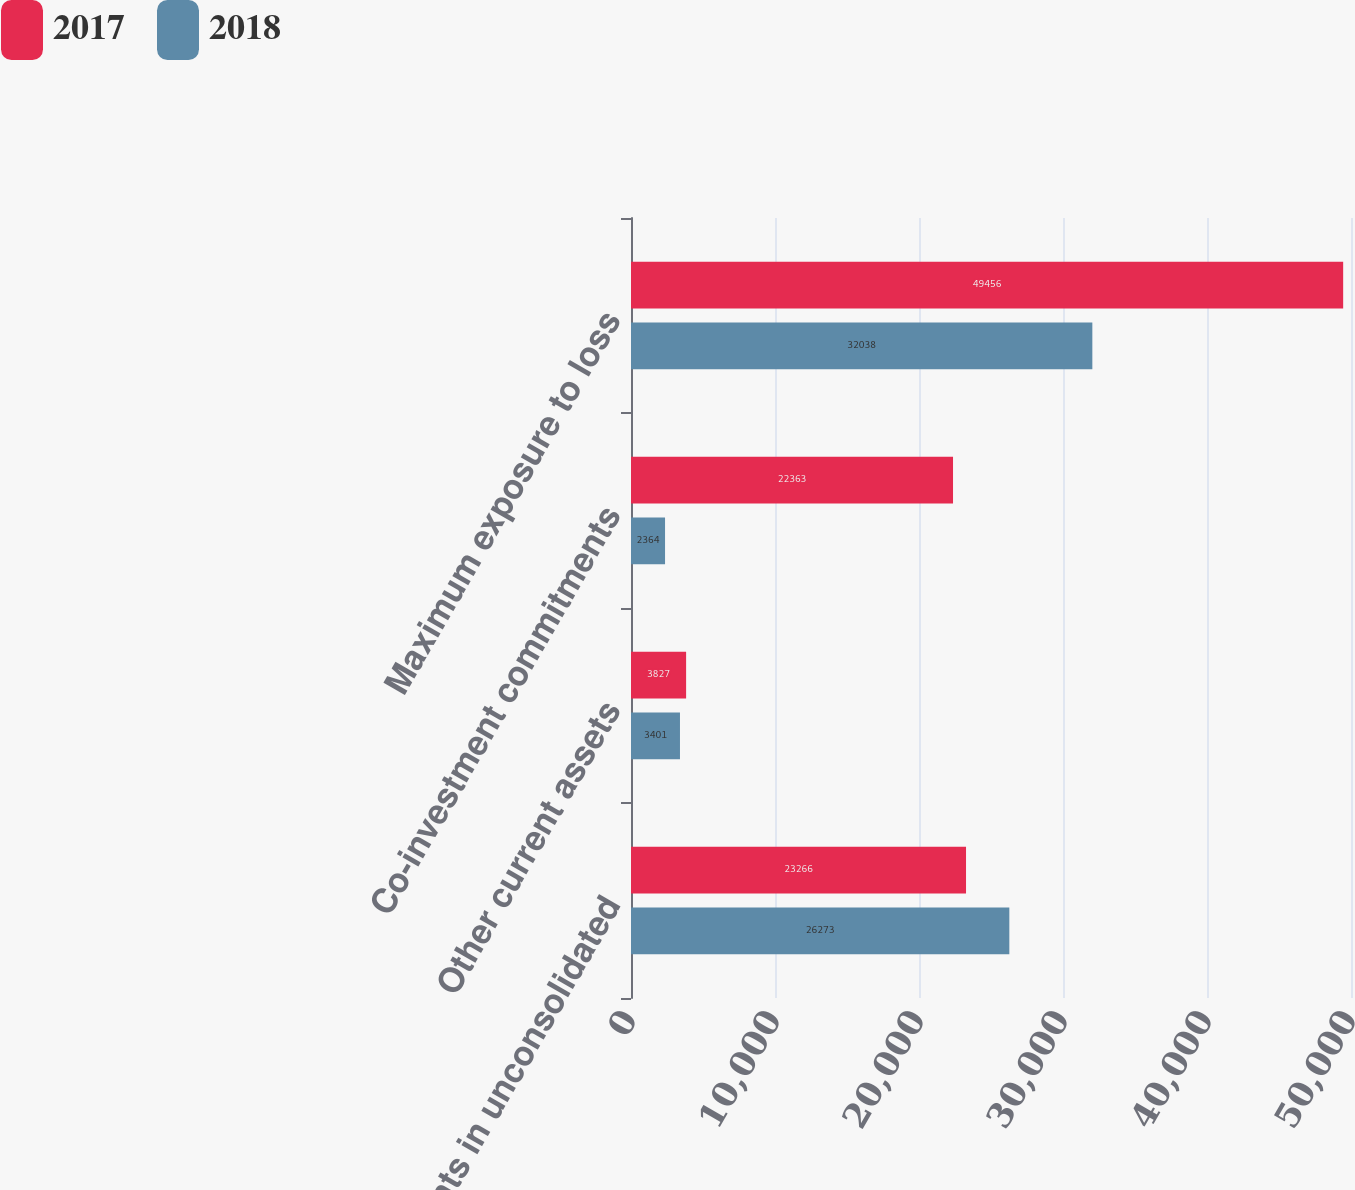Convert chart. <chart><loc_0><loc_0><loc_500><loc_500><stacked_bar_chart><ecel><fcel>Investments in unconsolidated<fcel>Other current assets<fcel>Co-investment commitments<fcel>Maximum exposure to loss<nl><fcel>2017<fcel>23266<fcel>3827<fcel>22363<fcel>49456<nl><fcel>2018<fcel>26273<fcel>3401<fcel>2364<fcel>32038<nl></chart> 